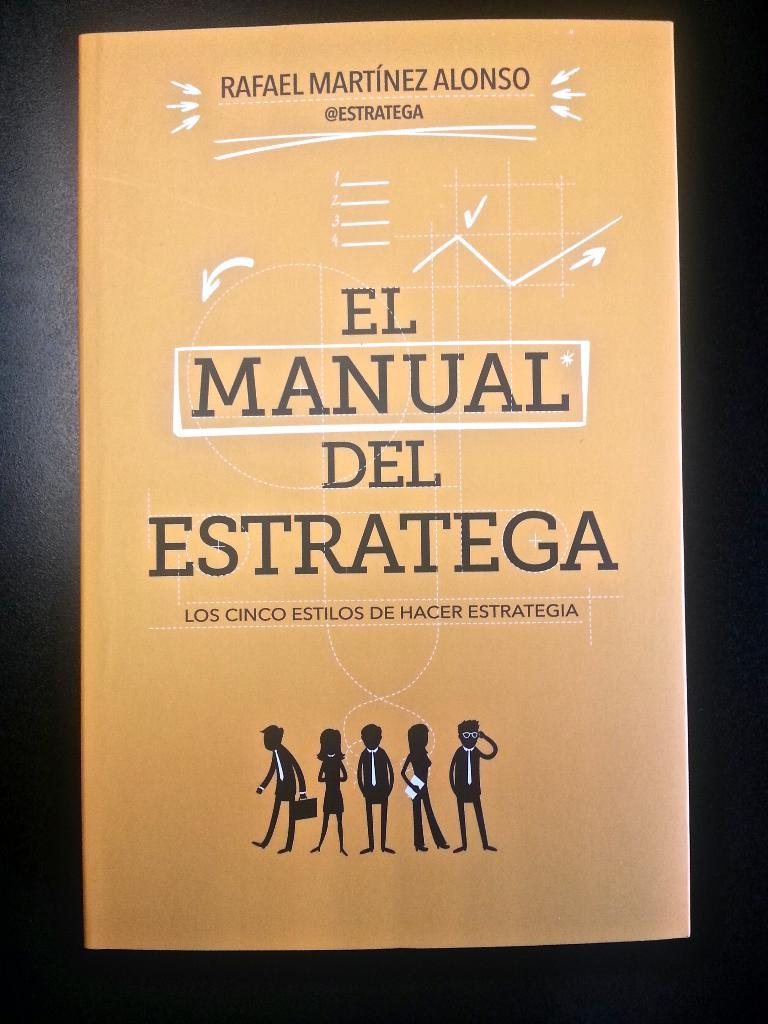<image>
Render a clear and concise summary of the photo. The book shown is written by the author Rafael Martinez Alonso. 